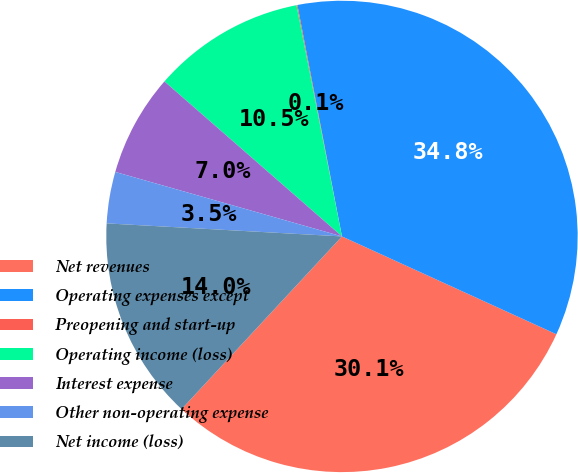Convert chart. <chart><loc_0><loc_0><loc_500><loc_500><pie_chart><fcel>Net revenues<fcel>Operating expenses except<fcel>Preopening and start-up<fcel>Operating income (loss)<fcel>Interest expense<fcel>Other non-operating expense<fcel>Net income (loss)<nl><fcel>30.1%<fcel>34.84%<fcel>0.06%<fcel>10.49%<fcel>7.01%<fcel>3.53%<fcel>13.97%<nl></chart> 